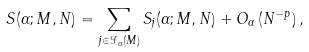<formula> <loc_0><loc_0><loc_500><loc_500>S ( \alpha ; M , N ) = \sum _ { j \in \mathcal { I } _ { \alpha } ( M ) } S _ { j } ( \alpha ; M , N ) + O _ { \alpha } \left ( N ^ { - p } \right ) ,</formula> 